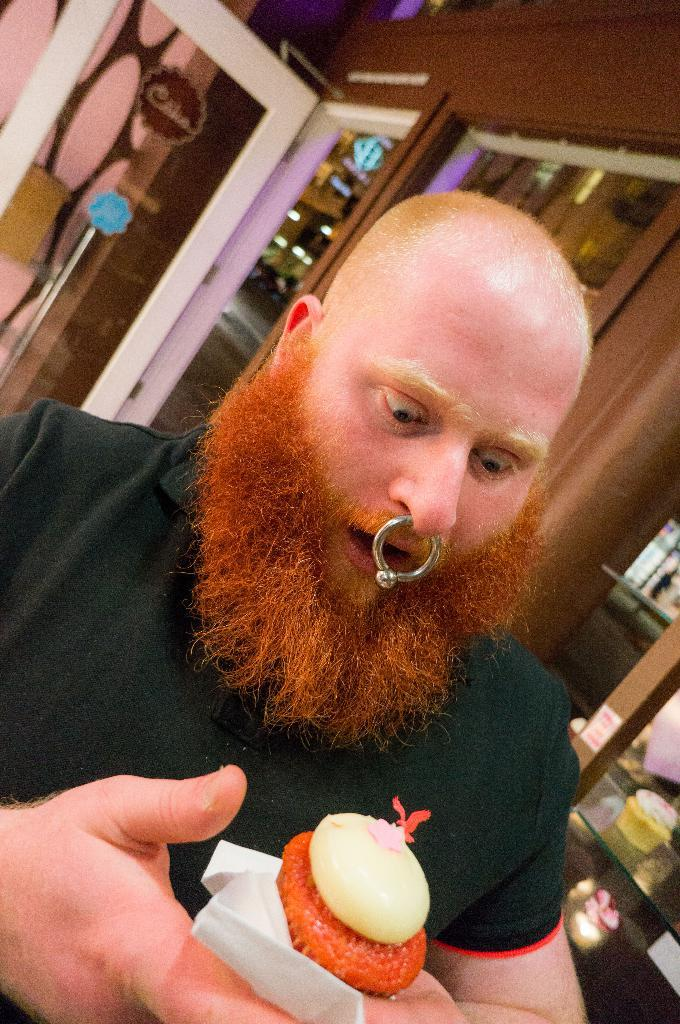What is the man in the image holding? The man is holding food in the image. What type of item might be used for cleaning or wiping in the image? Tissue papers are present in the image for cleaning or wiping. What can be seen in the background of the image? There is a table, an object on the table, stickers, a door, and a wall visible in the background of the image. What type of insect can be seen crawling on the man's arm in the image? There is no insect visible on the man's arm in the image. How does the man shake off the pest in the image? There is no pest present in the image, so shaking off a pest is not applicable. 